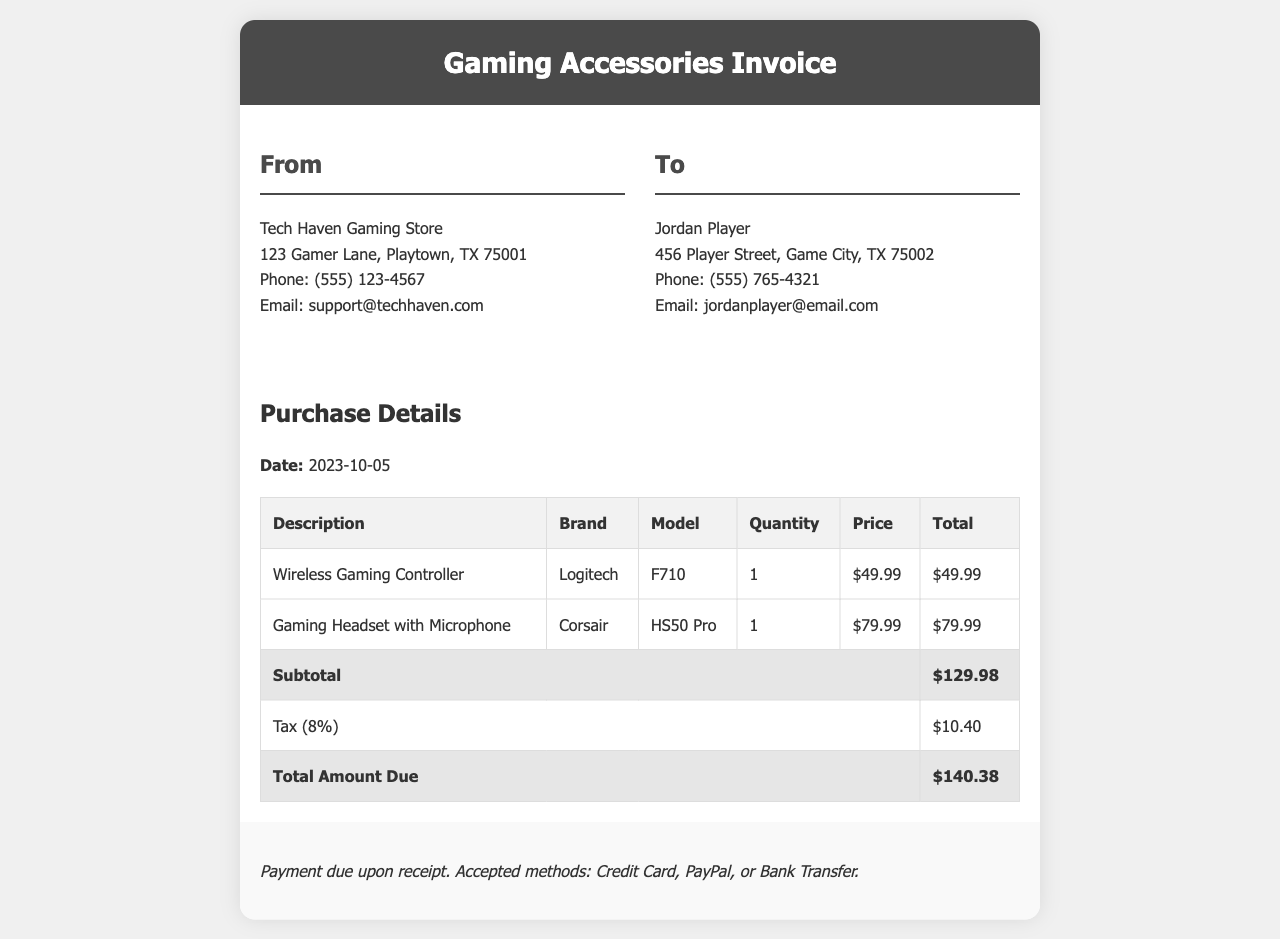What is the purchase date? The purchase date is specified in the document under the purchase details section, showing when the transaction occurred.
Answer: 2023-10-05 Who is the recipient of the invoice? The recipient's name and details are listed under the "To" section of the invoice document, identifying the individual the invoice is addressed to.
Answer: Jordan Player What is the subtotal amount? The subtotal amount is calculated by summing the total prices of all items before tax, shown in the totals section of the invoice.
Answer: $129.98 What is the tax rate applied? The tax rate in the document is mentioned alongside the tax amount, indicating the percentage used for calculating taxes on the subtotal.
Answer: 8% How many items are listed in the purchase details? The total number of distinct products is indicated by the number of rows in the purchase details table, specifically the items being sold.
Answer: 2 What brand is the gaming headset? The brand of the gaming headset is provided in the description of the headset listed in the invoice.
Answer: Corsair What is the total amount due? The total amount due combines the subtotal and tax, providing the final amount owed as listed in the invoice totals.
Answer: $140.38 What payment methods are accepted? The document outlines acceptable payment options in the payment terms section, detailing how the customer can settle the invoice.
Answer: Credit Card, PayPal, or Bank Transfer What is the model of the gaming controller? The model of the gaming controller is specified in the purchase details, providing clear identification of the exact product sold.
Answer: F710 